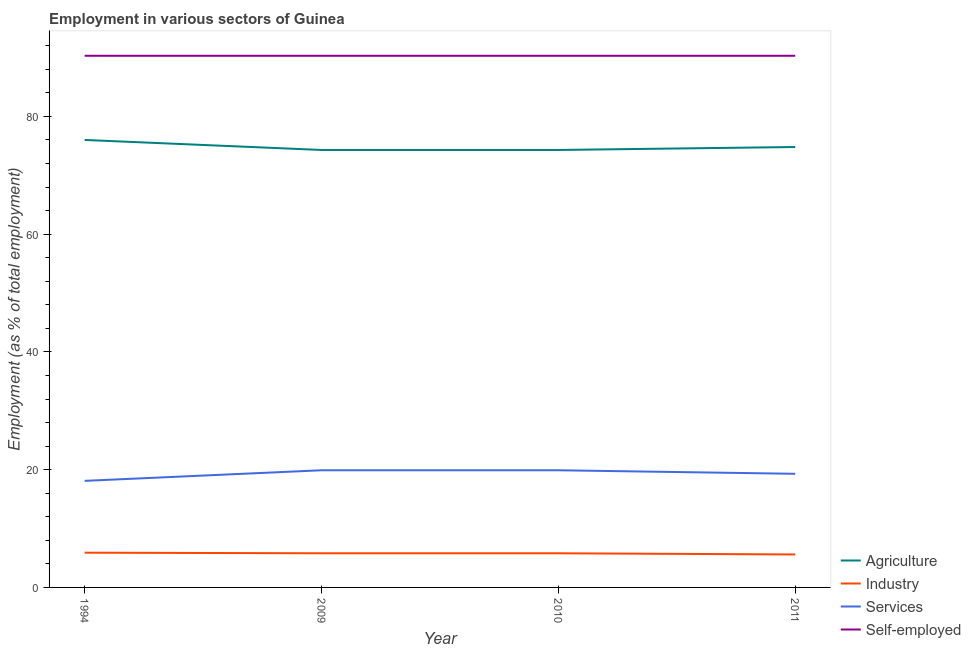What is the percentage of workers in industry in 2009?
Offer a very short reply. 5.8. Across all years, what is the maximum percentage of workers in industry?
Your response must be concise. 5.9. Across all years, what is the minimum percentage of workers in services?
Provide a succinct answer. 18.1. In which year was the percentage of workers in services maximum?
Give a very brief answer. 2009. What is the total percentage of self employed workers in the graph?
Your answer should be very brief. 361.2. What is the difference between the percentage of workers in industry in 1994 and that in 2011?
Your response must be concise. 0.3. What is the difference between the percentage of self employed workers in 2009 and the percentage of workers in services in 2010?
Your response must be concise. 70.4. What is the average percentage of workers in industry per year?
Offer a very short reply. 5.78. In the year 2009, what is the difference between the percentage of workers in agriculture and percentage of workers in services?
Give a very brief answer. 54.4. In how many years, is the percentage of workers in services greater than 60 %?
Provide a succinct answer. 0. What is the ratio of the percentage of workers in agriculture in 2009 to that in 2010?
Offer a terse response. 1. Is the difference between the percentage of workers in agriculture in 2009 and 2010 greater than the difference between the percentage of workers in services in 2009 and 2010?
Your response must be concise. No. What is the difference between the highest and the second highest percentage of workers in agriculture?
Provide a short and direct response. 1.2. What is the difference between the highest and the lowest percentage of workers in services?
Make the answer very short. 1.8. In how many years, is the percentage of workers in agriculture greater than the average percentage of workers in agriculture taken over all years?
Provide a short and direct response. 1. Is the sum of the percentage of workers in industry in 1994 and 2011 greater than the maximum percentage of self employed workers across all years?
Your answer should be very brief. No. Is the percentage of workers in agriculture strictly less than the percentage of workers in services over the years?
Keep it short and to the point. No. How many lines are there?
Offer a terse response. 4. Does the graph contain grids?
Your response must be concise. No. How many legend labels are there?
Your answer should be very brief. 4. How are the legend labels stacked?
Provide a succinct answer. Vertical. What is the title of the graph?
Ensure brevity in your answer.  Employment in various sectors of Guinea. Does "Negligence towards children" appear as one of the legend labels in the graph?
Your response must be concise. No. What is the label or title of the Y-axis?
Offer a very short reply. Employment (as % of total employment). What is the Employment (as % of total employment) of Agriculture in 1994?
Make the answer very short. 76. What is the Employment (as % of total employment) in Industry in 1994?
Ensure brevity in your answer.  5.9. What is the Employment (as % of total employment) of Services in 1994?
Offer a terse response. 18.1. What is the Employment (as % of total employment) in Self-employed in 1994?
Offer a terse response. 90.3. What is the Employment (as % of total employment) of Agriculture in 2009?
Make the answer very short. 74.3. What is the Employment (as % of total employment) in Industry in 2009?
Your response must be concise. 5.8. What is the Employment (as % of total employment) in Services in 2009?
Make the answer very short. 19.9. What is the Employment (as % of total employment) in Self-employed in 2009?
Keep it short and to the point. 90.3. What is the Employment (as % of total employment) in Agriculture in 2010?
Your answer should be very brief. 74.3. What is the Employment (as % of total employment) of Industry in 2010?
Give a very brief answer. 5.8. What is the Employment (as % of total employment) in Services in 2010?
Make the answer very short. 19.9. What is the Employment (as % of total employment) of Self-employed in 2010?
Give a very brief answer. 90.3. What is the Employment (as % of total employment) of Agriculture in 2011?
Offer a very short reply. 74.8. What is the Employment (as % of total employment) in Industry in 2011?
Your answer should be very brief. 5.6. What is the Employment (as % of total employment) in Services in 2011?
Make the answer very short. 19.3. What is the Employment (as % of total employment) in Self-employed in 2011?
Provide a short and direct response. 90.3. Across all years, what is the maximum Employment (as % of total employment) of Industry?
Provide a succinct answer. 5.9. Across all years, what is the maximum Employment (as % of total employment) in Services?
Provide a succinct answer. 19.9. Across all years, what is the maximum Employment (as % of total employment) of Self-employed?
Give a very brief answer. 90.3. Across all years, what is the minimum Employment (as % of total employment) of Agriculture?
Offer a terse response. 74.3. Across all years, what is the minimum Employment (as % of total employment) of Industry?
Offer a terse response. 5.6. Across all years, what is the minimum Employment (as % of total employment) of Services?
Your answer should be compact. 18.1. Across all years, what is the minimum Employment (as % of total employment) in Self-employed?
Provide a succinct answer. 90.3. What is the total Employment (as % of total employment) of Agriculture in the graph?
Provide a succinct answer. 299.4. What is the total Employment (as % of total employment) of Industry in the graph?
Your answer should be compact. 23.1. What is the total Employment (as % of total employment) in Services in the graph?
Offer a very short reply. 77.2. What is the total Employment (as % of total employment) of Self-employed in the graph?
Provide a short and direct response. 361.2. What is the difference between the Employment (as % of total employment) in Agriculture in 1994 and that in 2009?
Your answer should be very brief. 1.7. What is the difference between the Employment (as % of total employment) of Industry in 1994 and that in 2009?
Offer a very short reply. 0.1. What is the difference between the Employment (as % of total employment) of Services in 1994 and that in 2009?
Provide a succinct answer. -1.8. What is the difference between the Employment (as % of total employment) in Self-employed in 1994 and that in 2009?
Provide a short and direct response. 0. What is the difference between the Employment (as % of total employment) of Agriculture in 1994 and that in 2011?
Offer a very short reply. 1.2. What is the difference between the Employment (as % of total employment) of Self-employed in 2009 and that in 2010?
Your response must be concise. 0. What is the difference between the Employment (as % of total employment) of Self-employed in 2009 and that in 2011?
Your response must be concise. 0. What is the difference between the Employment (as % of total employment) of Agriculture in 1994 and the Employment (as % of total employment) of Industry in 2009?
Your answer should be compact. 70.2. What is the difference between the Employment (as % of total employment) in Agriculture in 1994 and the Employment (as % of total employment) in Services in 2009?
Make the answer very short. 56.1. What is the difference between the Employment (as % of total employment) of Agriculture in 1994 and the Employment (as % of total employment) of Self-employed in 2009?
Offer a very short reply. -14.3. What is the difference between the Employment (as % of total employment) in Industry in 1994 and the Employment (as % of total employment) in Services in 2009?
Your answer should be very brief. -14. What is the difference between the Employment (as % of total employment) of Industry in 1994 and the Employment (as % of total employment) of Self-employed in 2009?
Provide a succinct answer. -84.4. What is the difference between the Employment (as % of total employment) of Services in 1994 and the Employment (as % of total employment) of Self-employed in 2009?
Offer a very short reply. -72.2. What is the difference between the Employment (as % of total employment) in Agriculture in 1994 and the Employment (as % of total employment) in Industry in 2010?
Ensure brevity in your answer.  70.2. What is the difference between the Employment (as % of total employment) of Agriculture in 1994 and the Employment (as % of total employment) of Services in 2010?
Your response must be concise. 56.1. What is the difference between the Employment (as % of total employment) of Agriculture in 1994 and the Employment (as % of total employment) of Self-employed in 2010?
Give a very brief answer. -14.3. What is the difference between the Employment (as % of total employment) in Industry in 1994 and the Employment (as % of total employment) in Self-employed in 2010?
Provide a short and direct response. -84.4. What is the difference between the Employment (as % of total employment) in Services in 1994 and the Employment (as % of total employment) in Self-employed in 2010?
Provide a succinct answer. -72.2. What is the difference between the Employment (as % of total employment) of Agriculture in 1994 and the Employment (as % of total employment) of Industry in 2011?
Offer a very short reply. 70.4. What is the difference between the Employment (as % of total employment) in Agriculture in 1994 and the Employment (as % of total employment) in Services in 2011?
Provide a short and direct response. 56.7. What is the difference between the Employment (as % of total employment) in Agriculture in 1994 and the Employment (as % of total employment) in Self-employed in 2011?
Offer a very short reply. -14.3. What is the difference between the Employment (as % of total employment) of Industry in 1994 and the Employment (as % of total employment) of Self-employed in 2011?
Offer a terse response. -84.4. What is the difference between the Employment (as % of total employment) of Services in 1994 and the Employment (as % of total employment) of Self-employed in 2011?
Keep it short and to the point. -72.2. What is the difference between the Employment (as % of total employment) of Agriculture in 2009 and the Employment (as % of total employment) of Industry in 2010?
Keep it short and to the point. 68.5. What is the difference between the Employment (as % of total employment) in Agriculture in 2009 and the Employment (as % of total employment) in Services in 2010?
Give a very brief answer. 54.4. What is the difference between the Employment (as % of total employment) in Industry in 2009 and the Employment (as % of total employment) in Services in 2010?
Your response must be concise. -14.1. What is the difference between the Employment (as % of total employment) of Industry in 2009 and the Employment (as % of total employment) of Self-employed in 2010?
Offer a terse response. -84.5. What is the difference between the Employment (as % of total employment) of Services in 2009 and the Employment (as % of total employment) of Self-employed in 2010?
Offer a terse response. -70.4. What is the difference between the Employment (as % of total employment) in Agriculture in 2009 and the Employment (as % of total employment) in Industry in 2011?
Provide a succinct answer. 68.7. What is the difference between the Employment (as % of total employment) of Agriculture in 2009 and the Employment (as % of total employment) of Services in 2011?
Keep it short and to the point. 55. What is the difference between the Employment (as % of total employment) in Agriculture in 2009 and the Employment (as % of total employment) in Self-employed in 2011?
Your response must be concise. -16. What is the difference between the Employment (as % of total employment) of Industry in 2009 and the Employment (as % of total employment) of Self-employed in 2011?
Provide a succinct answer. -84.5. What is the difference between the Employment (as % of total employment) in Services in 2009 and the Employment (as % of total employment) in Self-employed in 2011?
Your response must be concise. -70.4. What is the difference between the Employment (as % of total employment) of Agriculture in 2010 and the Employment (as % of total employment) of Industry in 2011?
Your response must be concise. 68.7. What is the difference between the Employment (as % of total employment) of Industry in 2010 and the Employment (as % of total employment) of Services in 2011?
Your answer should be very brief. -13.5. What is the difference between the Employment (as % of total employment) in Industry in 2010 and the Employment (as % of total employment) in Self-employed in 2011?
Offer a very short reply. -84.5. What is the difference between the Employment (as % of total employment) in Services in 2010 and the Employment (as % of total employment) in Self-employed in 2011?
Keep it short and to the point. -70.4. What is the average Employment (as % of total employment) in Agriculture per year?
Provide a short and direct response. 74.85. What is the average Employment (as % of total employment) in Industry per year?
Offer a terse response. 5.78. What is the average Employment (as % of total employment) of Services per year?
Offer a terse response. 19.3. What is the average Employment (as % of total employment) of Self-employed per year?
Provide a succinct answer. 90.3. In the year 1994, what is the difference between the Employment (as % of total employment) in Agriculture and Employment (as % of total employment) in Industry?
Make the answer very short. 70.1. In the year 1994, what is the difference between the Employment (as % of total employment) in Agriculture and Employment (as % of total employment) in Services?
Ensure brevity in your answer.  57.9. In the year 1994, what is the difference between the Employment (as % of total employment) in Agriculture and Employment (as % of total employment) in Self-employed?
Provide a succinct answer. -14.3. In the year 1994, what is the difference between the Employment (as % of total employment) of Industry and Employment (as % of total employment) of Services?
Your answer should be very brief. -12.2. In the year 1994, what is the difference between the Employment (as % of total employment) in Industry and Employment (as % of total employment) in Self-employed?
Your answer should be very brief. -84.4. In the year 1994, what is the difference between the Employment (as % of total employment) in Services and Employment (as % of total employment) in Self-employed?
Your answer should be compact. -72.2. In the year 2009, what is the difference between the Employment (as % of total employment) of Agriculture and Employment (as % of total employment) of Industry?
Offer a terse response. 68.5. In the year 2009, what is the difference between the Employment (as % of total employment) of Agriculture and Employment (as % of total employment) of Services?
Provide a succinct answer. 54.4. In the year 2009, what is the difference between the Employment (as % of total employment) in Industry and Employment (as % of total employment) in Services?
Your answer should be very brief. -14.1. In the year 2009, what is the difference between the Employment (as % of total employment) in Industry and Employment (as % of total employment) in Self-employed?
Make the answer very short. -84.5. In the year 2009, what is the difference between the Employment (as % of total employment) of Services and Employment (as % of total employment) of Self-employed?
Make the answer very short. -70.4. In the year 2010, what is the difference between the Employment (as % of total employment) in Agriculture and Employment (as % of total employment) in Industry?
Provide a succinct answer. 68.5. In the year 2010, what is the difference between the Employment (as % of total employment) of Agriculture and Employment (as % of total employment) of Services?
Your response must be concise. 54.4. In the year 2010, what is the difference between the Employment (as % of total employment) of Agriculture and Employment (as % of total employment) of Self-employed?
Your answer should be very brief. -16. In the year 2010, what is the difference between the Employment (as % of total employment) of Industry and Employment (as % of total employment) of Services?
Give a very brief answer. -14.1. In the year 2010, what is the difference between the Employment (as % of total employment) of Industry and Employment (as % of total employment) of Self-employed?
Your answer should be compact. -84.5. In the year 2010, what is the difference between the Employment (as % of total employment) of Services and Employment (as % of total employment) of Self-employed?
Keep it short and to the point. -70.4. In the year 2011, what is the difference between the Employment (as % of total employment) of Agriculture and Employment (as % of total employment) of Industry?
Your answer should be very brief. 69.2. In the year 2011, what is the difference between the Employment (as % of total employment) in Agriculture and Employment (as % of total employment) in Services?
Offer a terse response. 55.5. In the year 2011, what is the difference between the Employment (as % of total employment) of Agriculture and Employment (as % of total employment) of Self-employed?
Your answer should be compact. -15.5. In the year 2011, what is the difference between the Employment (as % of total employment) of Industry and Employment (as % of total employment) of Services?
Provide a short and direct response. -13.7. In the year 2011, what is the difference between the Employment (as % of total employment) in Industry and Employment (as % of total employment) in Self-employed?
Provide a short and direct response. -84.7. In the year 2011, what is the difference between the Employment (as % of total employment) in Services and Employment (as % of total employment) in Self-employed?
Ensure brevity in your answer.  -71. What is the ratio of the Employment (as % of total employment) of Agriculture in 1994 to that in 2009?
Your answer should be compact. 1.02. What is the ratio of the Employment (as % of total employment) in Industry in 1994 to that in 2009?
Provide a succinct answer. 1.02. What is the ratio of the Employment (as % of total employment) of Services in 1994 to that in 2009?
Your response must be concise. 0.91. What is the ratio of the Employment (as % of total employment) of Agriculture in 1994 to that in 2010?
Make the answer very short. 1.02. What is the ratio of the Employment (as % of total employment) in Industry in 1994 to that in 2010?
Keep it short and to the point. 1.02. What is the ratio of the Employment (as % of total employment) in Services in 1994 to that in 2010?
Provide a short and direct response. 0.91. What is the ratio of the Employment (as % of total employment) in Self-employed in 1994 to that in 2010?
Your response must be concise. 1. What is the ratio of the Employment (as % of total employment) in Agriculture in 1994 to that in 2011?
Provide a succinct answer. 1.02. What is the ratio of the Employment (as % of total employment) of Industry in 1994 to that in 2011?
Provide a short and direct response. 1.05. What is the ratio of the Employment (as % of total employment) of Services in 1994 to that in 2011?
Your response must be concise. 0.94. What is the ratio of the Employment (as % of total employment) of Self-employed in 1994 to that in 2011?
Keep it short and to the point. 1. What is the ratio of the Employment (as % of total employment) in Agriculture in 2009 to that in 2010?
Offer a very short reply. 1. What is the ratio of the Employment (as % of total employment) of Services in 2009 to that in 2010?
Your answer should be compact. 1. What is the ratio of the Employment (as % of total employment) in Self-employed in 2009 to that in 2010?
Provide a short and direct response. 1. What is the ratio of the Employment (as % of total employment) in Agriculture in 2009 to that in 2011?
Keep it short and to the point. 0.99. What is the ratio of the Employment (as % of total employment) of Industry in 2009 to that in 2011?
Keep it short and to the point. 1.04. What is the ratio of the Employment (as % of total employment) in Services in 2009 to that in 2011?
Provide a short and direct response. 1.03. What is the ratio of the Employment (as % of total employment) in Self-employed in 2009 to that in 2011?
Give a very brief answer. 1. What is the ratio of the Employment (as % of total employment) of Industry in 2010 to that in 2011?
Give a very brief answer. 1.04. What is the ratio of the Employment (as % of total employment) of Services in 2010 to that in 2011?
Give a very brief answer. 1.03. What is the difference between the highest and the second highest Employment (as % of total employment) of Self-employed?
Your answer should be very brief. 0. What is the difference between the highest and the lowest Employment (as % of total employment) in Industry?
Provide a succinct answer. 0.3. What is the difference between the highest and the lowest Employment (as % of total employment) in Services?
Your answer should be very brief. 1.8. 